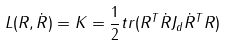<formula> <loc_0><loc_0><loc_500><loc_500>L ( R , \dot { R } ) = K = \frac { 1 } { 2 } t r ( R ^ { T } \dot { R } J _ { d } \dot { R } ^ { T } R )</formula> 